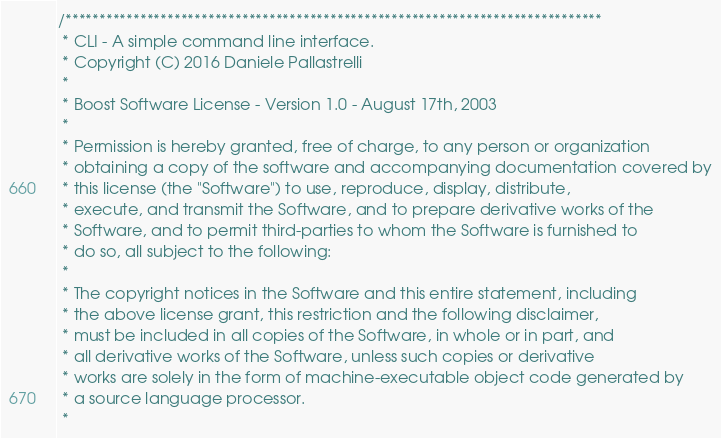<code> <loc_0><loc_0><loc_500><loc_500><_C_>/*******************************************************************************
 * CLI - A simple command line interface.
 * Copyright (C) 2016 Daniele Pallastrelli
 *
 * Boost Software License - Version 1.0 - August 17th, 2003
 *
 * Permission is hereby granted, free of charge, to any person or organization
 * obtaining a copy of the software and accompanying documentation covered by
 * this license (the "Software") to use, reproduce, display, distribute,
 * execute, and transmit the Software, and to prepare derivative works of the
 * Software, and to permit third-parties to whom the Software is furnished to
 * do so, all subject to the following:
 *
 * The copyright notices in the Software and this entire statement, including
 * the above license grant, this restriction and the following disclaimer,
 * must be included in all copies of the Software, in whole or in part, and
 * all derivative works of the Software, unless such copies or derivative
 * works are solely in the form of machine-executable object code generated by
 * a source language processor.
 *</code> 